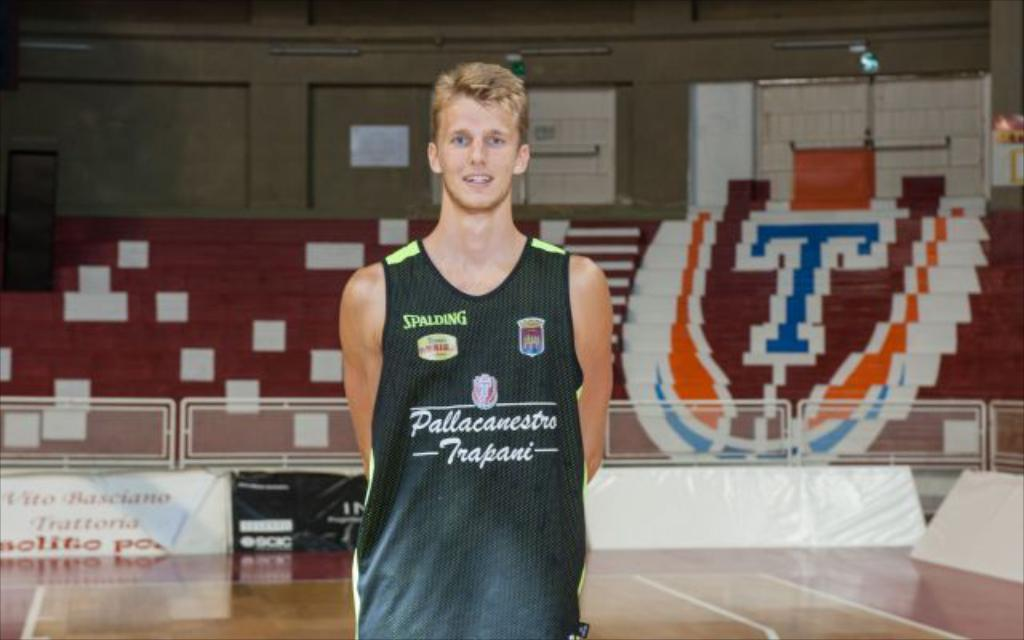<image>
Create a compact narrative representing the image presented. the letter T that is behind a guy 